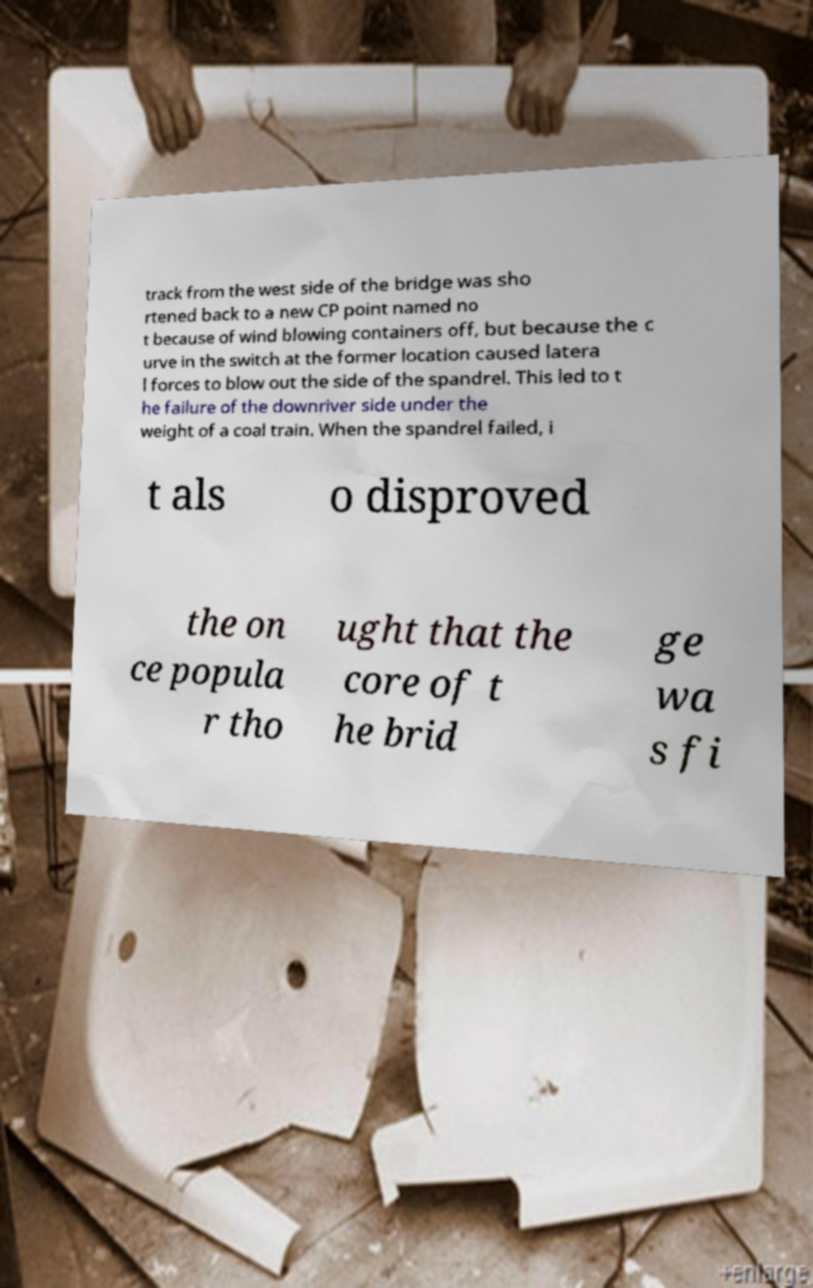Can you read and provide the text displayed in the image?This photo seems to have some interesting text. Can you extract and type it out for me? track from the west side of the bridge was sho rtened back to a new CP point named no t because of wind blowing containers off, but because the c urve in the switch at the former location caused latera l forces to blow out the side of the spandrel. This led to t he failure of the downriver side under the weight of a coal train. When the spandrel failed, i t als o disproved the on ce popula r tho ught that the core of t he brid ge wa s fi 